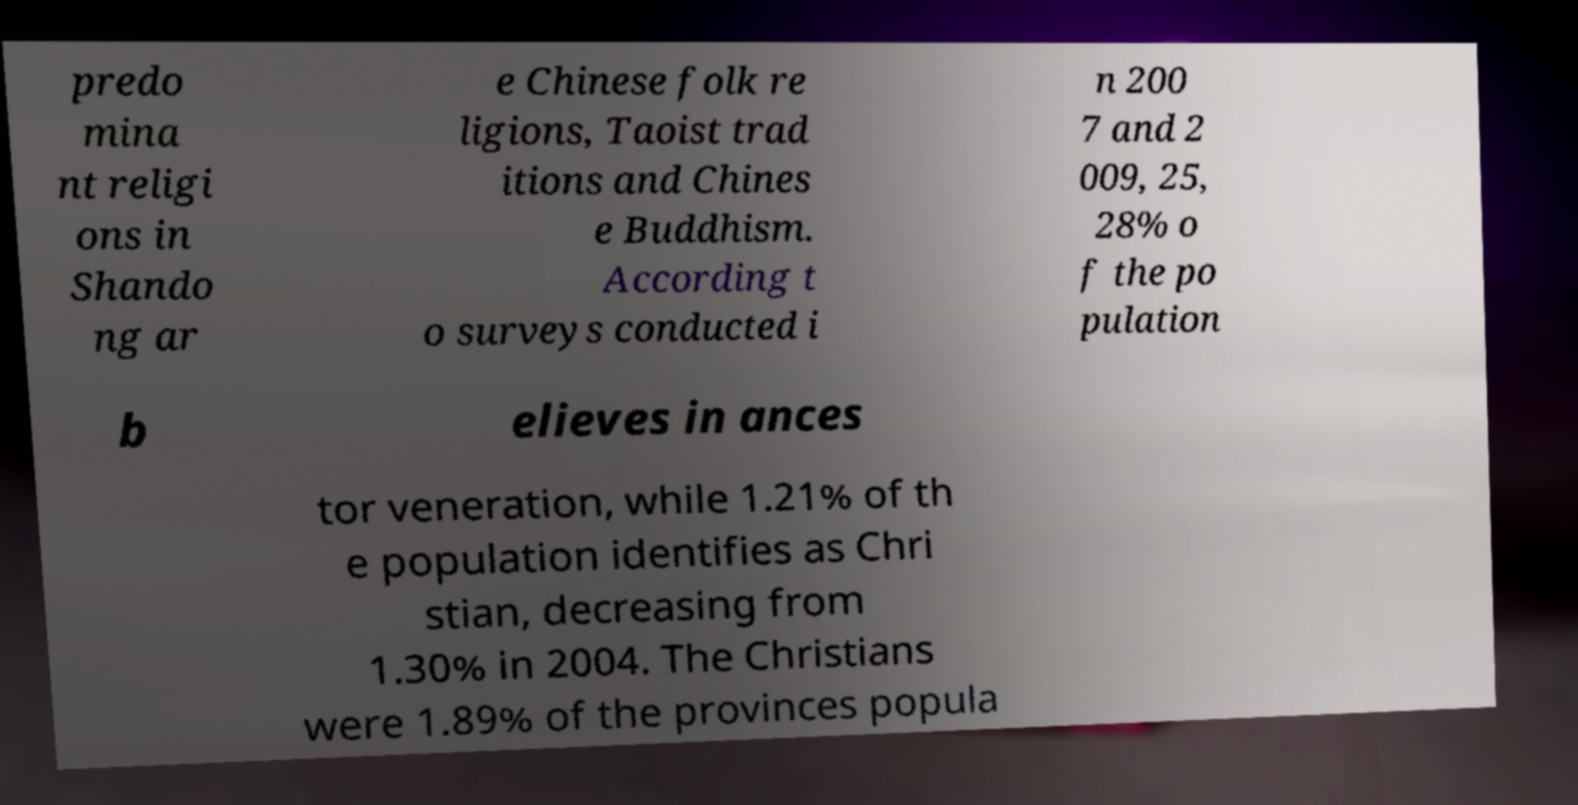There's text embedded in this image that I need extracted. Can you transcribe it verbatim? predo mina nt religi ons in Shando ng ar e Chinese folk re ligions, Taoist trad itions and Chines e Buddhism. According t o surveys conducted i n 200 7 and 2 009, 25, 28% o f the po pulation b elieves in ances tor veneration, while 1.21% of th e population identifies as Chri stian, decreasing from 1.30% in 2004. The Christians were 1.89% of the provinces popula 